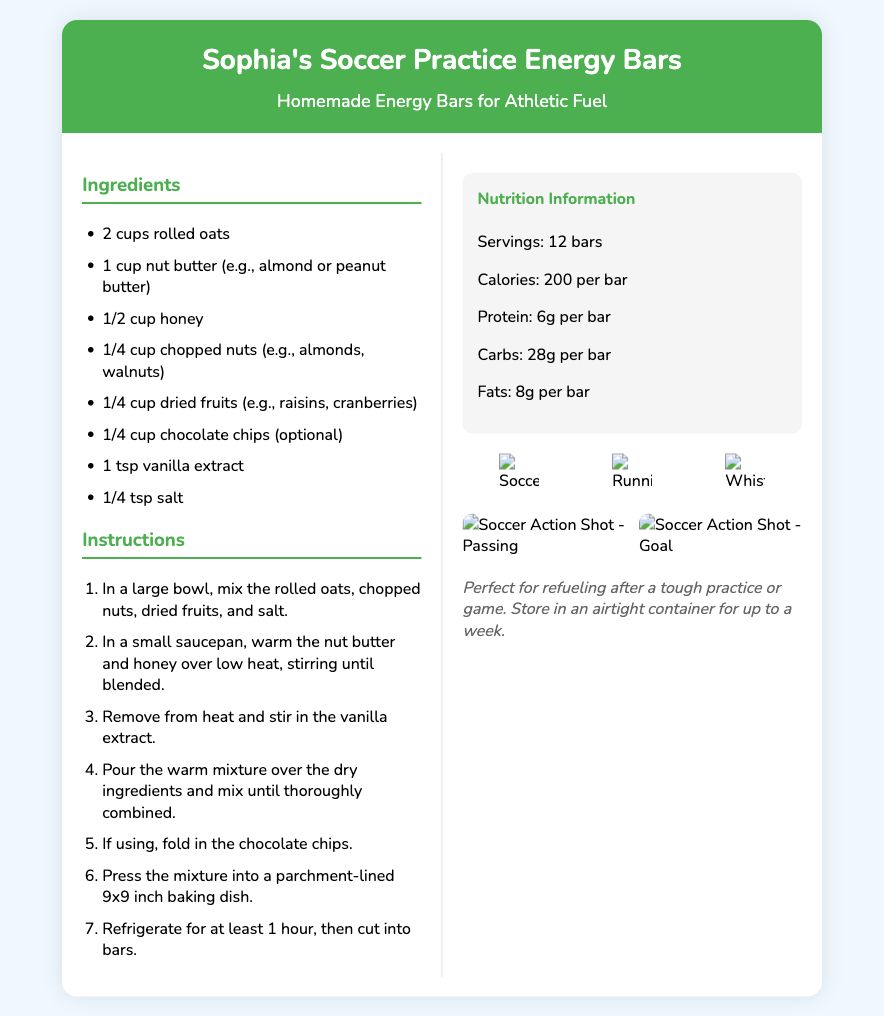What are the main ingredients? The main ingredients are listed in the ingredients section of the recipe card.
Answer: Rolled oats, nut butter, honey, nuts, dried fruits, chocolate chips, vanilla extract, salt How many servings does the recipe make? The number of servings is indicated in the nutrition information section of the recipe card.
Answer: 12 bars What is the total calories per bar? The calories per bar is found in the nutrition section of the recipe card.
Answer: 200 per bar What is one optional ingredient in the recipe? An optional ingredient is mentioned in the ingredients list.
Answer: Chocolate chips How long should the mixture be refrigerated? The required refrigeration time is included in the instructions section.
Answer: 1 hour What is the first step in the instructions? The first instruction step is outlined in the numbered list.
Answer: Mix the rolled oats, chopped nuts, dried fruits, and salt Which image represents a soccer ball? The icons section includes images, one of which represents a soccer ball.
Answer: soccer_ball.png What is the nutrition information for protein per bar? The protein content is specified in the nutrition section of the recipe card.
Answer: 6g per bar What should you use to line the baking dish? The instructions mention what to use to line the baking dish.
Answer: Parchment paper 